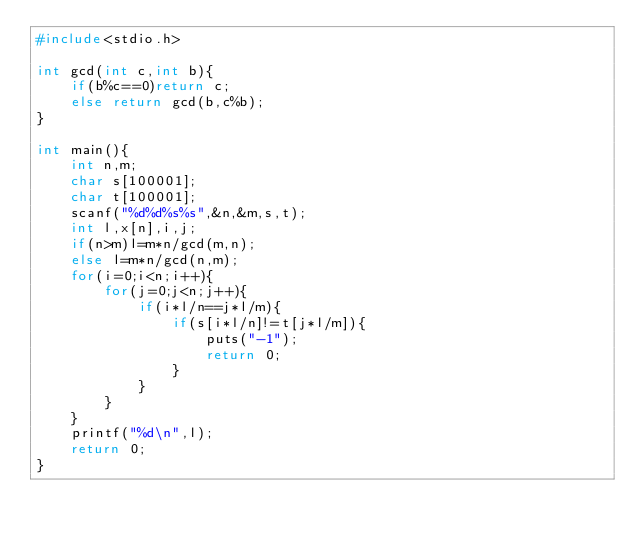Convert code to text. <code><loc_0><loc_0><loc_500><loc_500><_C_>#include<stdio.h>

int gcd(int c,int b){
	if(b%c==0)return c;
	else return gcd(b,c%b);
}

int main(){
	int n,m;
	char s[100001];
	char t[100001];
	scanf("%d%d%s%s",&n,&m,s,t);
	int l,x[n],i,j;
	if(n>m)l=m*n/gcd(m,n);
	else l=m*n/gcd(n,m);
	for(i=0;i<n;i++){
		for(j=0;j<n;j++){
			if(i*l/n==j*l/m){
				if(s[i*l/n]!=t[j*l/m]){
					puts("-1");
					return 0;
				}
			}
		}
	}
	printf("%d\n",l);
	return 0;
}</code> 